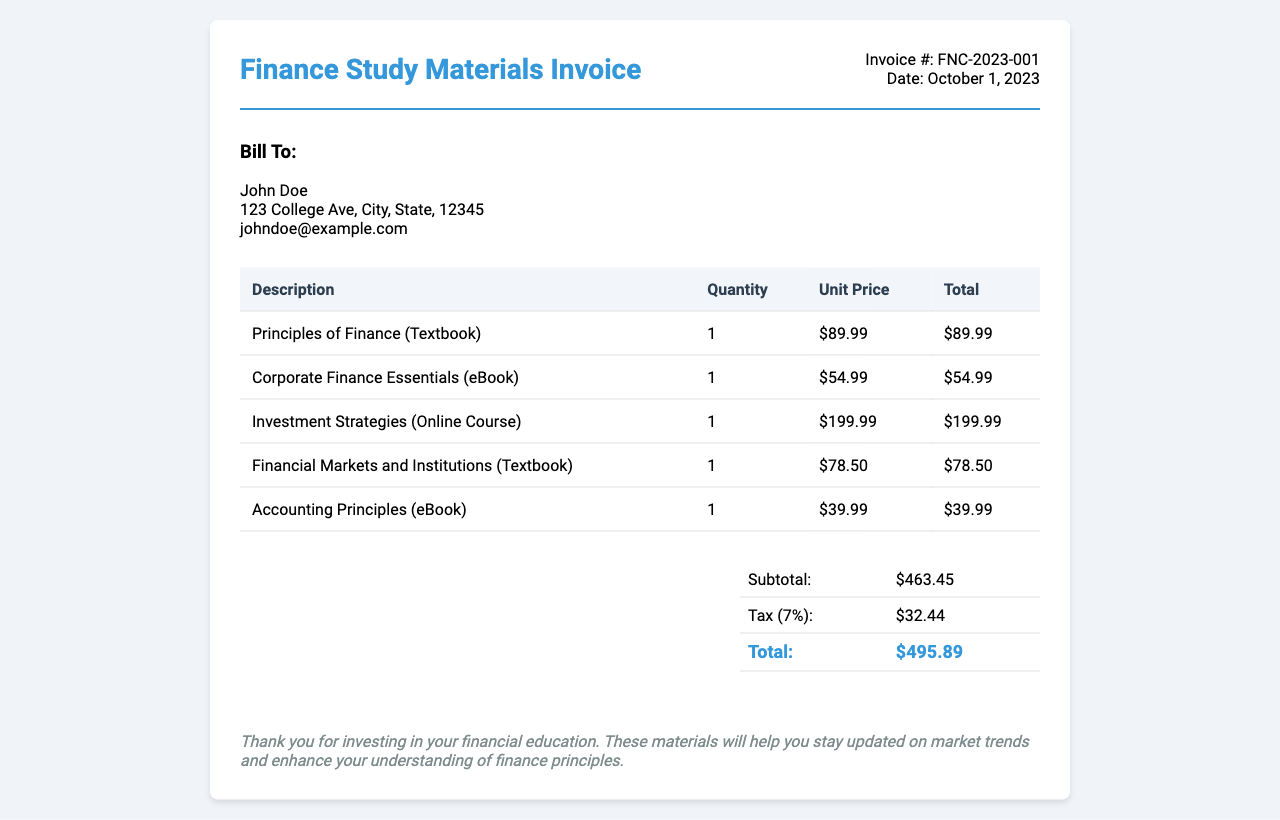What is the invoice number? The document specifies the invoice number as FNC-2023-001.
Answer: FNC-2023-001 Who is the bill to? The bill is addressed to John Doe, as mentioned in the document.
Answer: John Doe What is the date of the invoice? The date provided in the invoice is October 1, 2023.
Answer: October 1, 2023 What is the subtotal amount? The subtotal amount is stated before tax, which is $463.45.
Answer: $463.45 What is the tax percentage applied? The tax percentage mentioned in the document is 7%.
Answer: 7% How much is the total amount due? The total amount due after tax is clearly indicated as $495.89.
Answer: $495.89 Which textbook costs $89.99? The invoice lists "Principles of Finance" as the textbook priced at $89.99.
Answer: Principles of Finance How many online resources are listed? There is a total of 3 online resources noted in the document.
Answer: 3 What is the price of the eBook "Corporate Finance Essentials"? The price for the eBook "Corporate Finance Essentials" is indicated as $54.99.
Answer: $54.99 What is the note at the bottom of the invoice about? The note expresses gratitude for investing in financial education and mentions the benefits of the materials.
Answer: Thank you for investing in your financial education 